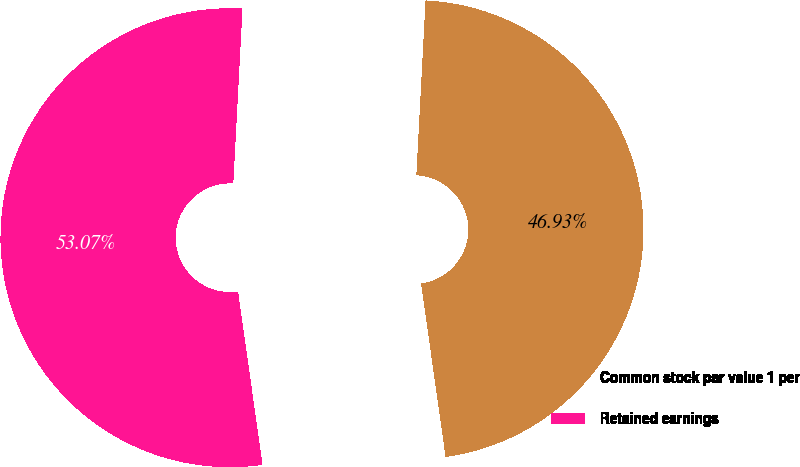Convert chart. <chart><loc_0><loc_0><loc_500><loc_500><pie_chart><fcel>Common stock par value 1 per<fcel>Retained earnings<nl><fcel>46.93%<fcel>53.07%<nl></chart> 